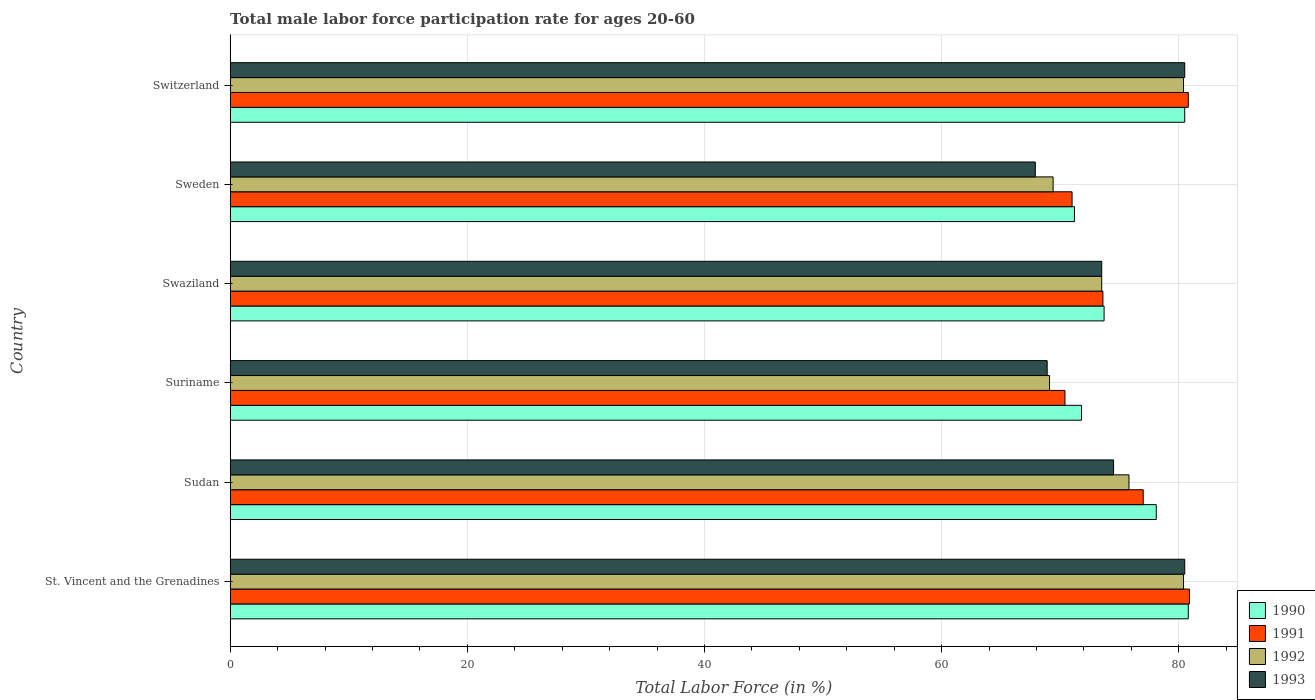How many different coloured bars are there?
Provide a short and direct response. 4. How many groups of bars are there?
Ensure brevity in your answer.  6. Are the number of bars per tick equal to the number of legend labels?
Offer a very short reply. Yes. Are the number of bars on each tick of the Y-axis equal?
Provide a succinct answer. Yes. How many bars are there on the 1st tick from the bottom?
Provide a succinct answer. 4. What is the label of the 1st group of bars from the top?
Provide a succinct answer. Switzerland. In how many cases, is the number of bars for a given country not equal to the number of legend labels?
Offer a very short reply. 0. What is the male labor force participation rate in 1991 in St. Vincent and the Grenadines?
Ensure brevity in your answer.  80.9. Across all countries, what is the maximum male labor force participation rate in 1993?
Your answer should be compact. 80.5. Across all countries, what is the minimum male labor force participation rate in 1992?
Keep it short and to the point. 69.1. In which country was the male labor force participation rate in 1993 maximum?
Your answer should be very brief. St. Vincent and the Grenadines. In which country was the male labor force participation rate in 1993 minimum?
Offer a terse response. Sweden. What is the total male labor force participation rate in 1993 in the graph?
Ensure brevity in your answer.  445.8. What is the difference between the male labor force participation rate in 1990 in Sweden and that in Switzerland?
Your response must be concise. -9.3. What is the difference between the male labor force participation rate in 1992 in Sudan and the male labor force participation rate in 1990 in Switzerland?
Your answer should be very brief. -4.7. What is the average male labor force participation rate in 1990 per country?
Offer a very short reply. 76.02. What is the difference between the male labor force participation rate in 1992 and male labor force participation rate in 1991 in Sweden?
Provide a succinct answer. -1.6. In how many countries, is the male labor force participation rate in 1993 greater than 44 %?
Your answer should be very brief. 6. What is the ratio of the male labor force participation rate in 1993 in Swaziland to that in Sweden?
Provide a succinct answer. 1.08. Is the male labor force participation rate in 1993 in St. Vincent and the Grenadines less than that in Suriname?
Offer a terse response. No. What is the difference between the highest and the second highest male labor force participation rate in 1991?
Your response must be concise. 0.1. Is the sum of the male labor force participation rate in 1990 in Sudan and Switzerland greater than the maximum male labor force participation rate in 1991 across all countries?
Give a very brief answer. Yes. Is it the case that in every country, the sum of the male labor force participation rate in 1992 and male labor force participation rate in 1993 is greater than the male labor force participation rate in 1991?
Your answer should be very brief. Yes. How many bars are there?
Keep it short and to the point. 24. How many countries are there in the graph?
Ensure brevity in your answer.  6. What is the difference between two consecutive major ticks on the X-axis?
Offer a very short reply. 20. Where does the legend appear in the graph?
Keep it short and to the point. Bottom right. How are the legend labels stacked?
Make the answer very short. Vertical. What is the title of the graph?
Keep it short and to the point. Total male labor force participation rate for ages 20-60. Does "1963" appear as one of the legend labels in the graph?
Provide a succinct answer. No. What is the label or title of the X-axis?
Ensure brevity in your answer.  Total Labor Force (in %). What is the label or title of the Y-axis?
Provide a succinct answer. Country. What is the Total Labor Force (in %) in 1990 in St. Vincent and the Grenadines?
Your answer should be very brief. 80.8. What is the Total Labor Force (in %) of 1991 in St. Vincent and the Grenadines?
Provide a succinct answer. 80.9. What is the Total Labor Force (in %) in 1992 in St. Vincent and the Grenadines?
Offer a very short reply. 80.4. What is the Total Labor Force (in %) in 1993 in St. Vincent and the Grenadines?
Your answer should be compact. 80.5. What is the Total Labor Force (in %) of 1990 in Sudan?
Provide a succinct answer. 78.1. What is the Total Labor Force (in %) in 1992 in Sudan?
Provide a short and direct response. 75.8. What is the Total Labor Force (in %) in 1993 in Sudan?
Provide a short and direct response. 74.5. What is the Total Labor Force (in %) of 1990 in Suriname?
Your answer should be very brief. 71.8. What is the Total Labor Force (in %) of 1991 in Suriname?
Ensure brevity in your answer.  70.4. What is the Total Labor Force (in %) in 1992 in Suriname?
Your answer should be very brief. 69.1. What is the Total Labor Force (in %) in 1993 in Suriname?
Your answer should be compact. 68.9. What is the Total Labor Force (in %) of 1990 in Swaziland?
Offer a terse response. 73.7. What is the Total Labor Force (in %) in 1991 in Swaziland?
Give a very brief answer. 73.6. What is the Total Labor Force (in %) of 1992 in Swaziland?
Offer a terse response. 73.5. What is the Total Labor Force (in %) in 1993 in Swaziland?
Your answer should be very brief. 73.5. What is the Total Labor Force (in %) in 1990 in Sweden?
Keep it short and to the point. 71.2. What is the Total Labor Force (in %) of 1992 in Sweden?
Ensure brevity in your answer.  69.4. What is the Total Labor Force (in %) in 1993 in Sweden?
Give a very brief answer. 67.9. What is the Total Labor Force (in %) of 1990 in Switzerland?
Give a very brief answer. 80.5. What is the Total Labor Force (in %) of 1991 in Switzerland?
Your answer should be compact. 80.8. What is the Total Labor Force (in %) of 1992 in Switzerland?
Your answer should be compact. 80.4. What is the Total Labor Force (in %) in 1993 in Switzerland?
Your answer should be compact. 80.5. Across all countries, what is the maximum Total Labor Force (in %) of 1990?
Offer a terse response. 80.8. Across all countries, what is the maximum Total Labor Force (in %) in 1991?
Give a very brief answer. 80.9. Across all countries, what is the maximum Total Labor Force (in %) of 1992?
Your answer should be very brief. 80.4. Across all countries, what is the maximum Total Labor Force (in %) of 1993?
Your response must be concise. 80.5. Across all countries, what is the minimum Total Labor Force (in %) in 1990?
Your response must be concise. 71.2. Across all countries, what is the minimum Total Labor Force (in %) of 1991?
Your answer should be compact. 70.4. Across all countries, what is the minimum Total Labor Force (in %) in 1992?
Keep it short and to the point. 69.1. Across all countries, what is the minimum Total Labor Force (in %) in 1993?
Your answer should be compact. 67.9. What is the total Total Labor Force (in %) in 1990 in the graph?
Your response must be concise. 456.1. What is the total Total Labor Force (in %) in 1991 in the graph?
Your answer should be compact. 453.7. What is the total Total Labor Force (in %) of 1992 in the graph?
Make the answer very short. 448.6. What is the total Total Labor Force (in %) in 1993 in the graph?
Offer a terse response. 445.8. What is the difference between the Total Labor Force (in %) of 1990 in St. Vincent and the Grenadines and that in Sudan?
Make the answer very short. 2.7. What is the difference between the Total Labor Force (in %) in 1991 in St. Vincent and the Grenadines and that in Sudan?
Your answer should be compact. 3.9. What is the difference between the Total Labor Force (in %) in 1992 in St. Vincent and the Grenadines and that in Sudan?
Give a very brief answer. 4.6. What is the difference between the Total Labor Force (in %) of 1993 in St. Vincent and the Grenadines and that in Sudan?
Provide a short and direct response. 6. What is the difference between the Total Labor Force (in %) in 1990 in St. Vincent and the Grenadines and that in Suriname?
Offer a very short reply. 9. What is the difference between the Total Labor Force (in %) in 1991 in St. Vincent and the Grenadines and that in Suriname?
Provide a short and direct response. 10.5. What is the difference between the Total Labor Force (in %) of 1992 in St. Vincent and the Grenadines and that in Suriname?
Offer a terse response. 11.3. What is the difference between the Total Labor Force (in %) in 1993 in St. Vincent and the Grenadines and that in Suriname?
Provide a succinct answer. 11.6. What is the difference between the Total Labor Force (in %) in 1990 in St. Vincent and the Grenadines and that in Swaziland?
Offer a very short reply. 7.1. What is the difference between the Total Labor Force (in %) in 1991 in St. Vincent and the Grenadines and that in Swaziland?
Offer a terse response. 7.3. What is the difference between the Total Labor Force (in %) in 1992 in St. Vincent and the Grenadines and that in Swaziland?
Keep it short and to the point. 6.9. What is the difference between the Total Labor Force (in %) in 1993 in St. Vincent and the Grenadines and that in Swaziland?
Your answer should be compact. 7. What is the difference between the Total Labor Force (in %) in 1993 in St. Vincent and the Grenadines and that in Sweden?
Provide a short and direct response. 12.6. What is the difference between the Total Labor Force (in %) in 1990 in St. Vincent and the Grenadines and that in Switzerland?
Make the answer very short. 0.3. What is the difference between the Total Labor Force (in %) in 1993 in St. Vincent and the Grenadines and that in Switzerland?
Offer a terse response. 0. What is the difference between the Total Labor Force (in %) in 1991 in Sudan and that in Suriname?
Offer a very short reply. 6.6. What is the difference between the Total Labor Force (in %) in 1992 in Sudan and that in Suriname?
Provide a short and direct response. 6.7. What is the difference between the Total Labor Force (in %) of 1993 in Sudan and that in Suriname?
Give a very brief answer. 5.6. What is the difference between the Total Labor Force (in %) in 1990 in Sudan and that in Swaziland?
Offer a terse response. 4.4. What is the difference between the Total Labor Force (in %) of 1991 in Sudan and that in Sweden?
Give a very brief answer. 6. What is the difference between the Total Labor Force (in %) in 1991 in Sudan and that in Switzerland?
Your response must be concise. -3.8. What is the difference between the Total Labor Force (in %) in 1992 in Sudan and that in Switzerland?
Ensure brevity in your answer.  -4.6. What is the difference between the Total Labor Force (in %) of 1990 in Suriname and that in Swaziland?
Your answer should be very brief. -1.9. What is the difference between the Total Labor Force (in %) of 1992 in Suriname and that in Swaziland?
Offer a very short reply. -4.4. What is the difference between the Total Labor Force (in %) of 1990 in Suriname and that in Sweden?
Ensure brevity in your answer.  0.6. What is the difference between the Total Labor Force (in %) in 1991 in Suriname and that in Sweden?
Keep it short and to the point. -0.6. What is the difference between the Total Labor Force (in %) of 1993 in Suriname and that in Sweden?
Your response must be concise. 1. What is the difference between the Total Labor Force (in %) of 1990 in Suriname and that in Switzerland?
Offer a terse response. -8.7. What is the difference between the Total Labor Force (in %) in 1992 in Suriname and that in Switzerland?
Offer a very short reply. -11.3. What is the difference between the Total Labor Force (in %) of 1993 in Suriname and that in Switzerland?
Give a very brief answer. -11.6. What is the difference between the Total Labor Force (in %) of 1990 in Swaziland and that in Sweden?
Your answer should be very brief. 2.5. What is the difference between the Total Labor Force (in %) of 1992 in Swaziland and that in Sweden?
Provide a succinct answer. 4.1. What is the difference between the Total Labor Force (in %) in 1991 in Swaziland and that in Switzerland?
Your response must be concise. -7.2. What is the difference between the Total Labor Force (in %) of 1993 in Swaziland and that in Switzerland?
Your answer should be compact. -7. What is the difference between the Total Labor Force (in %) in 1993 in Sweden and that in Switzerland?
Give a very brief answer. -12.6. What is the difference between the Total Labor Force (in %) in 1992 in St. Vincent and the Grenadines and the Total Labor Force (in %) in 1993 in Sudan?
Your answer should be very brief. 5.9. What is the difference between the Total Labor Force (in %) in 1990 in St. Vincent and the Grenadines and the Total Labor Force (in %) in 1991 in Suriname?
Provide a succinct answer. 10.4. What is the difference between the Total Labor Force (in %) in 1991 in St. Vincent and the Grenadines and the Total Labor Force (in %) in 1992 in Suriname?
Ensure brevity in your answer.  11.8. What is the difference between the Total Labor Force (in %) of 1990 in St. Vincent and the Grenadines and the Total Labor Force (in %) of 1991 in Swaziland?
Offer a terse response. 7.2. What is the difference between the Total Labor Force (in %) in 1990 in St. Vincent and the Grenadines and the Total Labor Force (in %) in 1993 in Sweden?
Give a very brief answer. 12.9. What is the difference between the Total Labor Force (in %) of 1991 in St. Vincent and the Grenadines and the Total Labor Force (in %) of 1993 in Sweden?
Make the answer very short. 13. What is the difference between the Total Labor Force (in %) of 1992 in St. Vincent and the Grenadines and the Total Labor Force (in %) of 1993 in Sweden?
Ensure brevity in your answer.  12.5. What is the difference between the Total Labor Force (in %) of 1990 in St. Vincent and the Grenadines and the Total Labor Force (in %) of 1991 in Switzerland?
Keep it short and to the point. 0. What is the difference between the Total Labor Force (in %) in 1991 in St. Vincent and the Grenadines and the Total Labor Force (in %) in 1993 in Switzerland?
Give a very brief answer. 0.4. What is the difference between the Total Labor Force (in %) in 1990 in Sudan and the Total Labor Force (in %) in 1992 in Suriname?
Offer a terse response. 9. What is the difference between the Total Labor Force (in %) in 1990 in Sudan and the Total Labor Force (in %) in 1993 in Suriname?
Offer a very short reply. 9.2. What is the difference between the Total Labor Force (in %) in 1991 in Sudan and the Total Labor Force (in %) in 1992 in Suriname?
Offer a very short reply. 7.9. What is the difference between the Total Labor Force (in %) of 1991 in Sudan and the Total Labor Force (in %) of 1993 in Suriname?
Give a very brief answer. 8.1. What is the difference between the Total Labor Force (in %) of 1990 in Sudan and the Total Labor Force (in %) of 1992 in Swaziland?
Your response must be concise. 4.6. What is the difference between the Total Labor Force (in %) of 1991 in Sudan and the Total Labor Force (in %) of 1993 in Swaziland?
Your answer should be compact. 3.5. What is the difference between the Total Labor Force (in %) of 1990 in Sudan and the Total Labor Force (in %) of 1991 in Sweden?
Offer a very short reply. 7.1. What is the difference between the Total Labor Force (in %) of 1990 in Sudan and the Total Labor Force (in %) of 1992 in Sweden?
Ensure brevity in your answer.  8.7. What is the difference between the Total Labor Force (in %) of 1990 in Sudan and the Total Labor Force (in %) of 1993 in Sweden?
Your answer should be compact. 10.2. What is the difference between the Total Labor Force (in %) of 1991 in Sudan and the Total Labor Force (in %) of 1993 in Sweden?
Provide a short and direct response. 9.1. What is the difference between the Total Labor Force (in %) of 1992 in Sudan and the Total Labor Force (in %) of 1993 in Sweden?
Your response must be concise. 7.9. What is the difference between the Total Labor Force (in %) in 1990 in Sudan and the Total Labor Force (in %) in 1991 in Switzerland?
Provide a succinct answer. -2.7. What is the difference between the Total Labor Force (in %) of 1990 in Sudan and the Total Labor Force (in %) of 1992 in Switzerland?
Make the answer very short. -2.3. What is the difference between the Total Labor Force (in %) of 1990 in Sudan and the Total Labor Force (in %) of 1993 in Switzerland?
Your response must be concise. -2.4. What is the difference between the Total Labor Force (in %) of 1992 in Sudan and the Total Labor Force (in %) of 1993 in Switzerland?
Offer a very short reply. -4.7. What is the difference between the Total Labor Force (in %) in 1990 in Suriname and the Total Labor Force (in %) in 1991 in Swaziland?
Your response must be concise. -1.8. What is the difference between the Total Labor Force (in %) of 1991 in Suriname and the Total Labor Force (in %) of 1993 in Swaziland?
Offer a terse response. -3.1. What is the difference between the Total Labor Force (in %) of 1992 in Suriname and the Total Labor Force (in %) of 1993 in Swaziland?
Keep it short and to the point. -4.4. What is the difference between the Total Labor Force (in %) in 1990 in Suriname and the Total Labor Force (in %) in 1991 in Sweden?
Offer a very short reply. 0.8. What is the difference between the Total Labor Force (in %) in 1991 in Suriname and the Total Labor Force (in %) in 1992 in Sweden?
Give a very brief answer. 1. What is the difference between the Total Labor Force (in %) of 1990 in Suriname and the Total Labor Force (in %) of 1991 in Switzerland?
Your answer should be compact. -9. What is the difference between the Total Labor Force (in %) of 1990 in Suriname and the Total Labor Force (in %) of 1993 in Switzerland?
Provide a succinct answer. -8.7. What is the difference between the Total Labor Force (in %) of 1991 in Suriname and the Total Labor Force (in %) of 1992 in Switzerland?
Keep it short and to the point. -10. What is the difference between the Total Labor Force (in %) of 1992 in Suriname and the Total Labor Force (in %) of 1993 in Switzerland?
Your answer should be very brief. -11.4. What is the difference between the Total Labor Force (in %) of 1990 in Swaziland and the Total Labor Force (in %) of 1991 in Sweden?
Keep it short and to the point. 2.7. What is the difference between the Total Labor Force (in %) of 1990 in Swaziland and the Total Labor Force (in %) of 1993 in Sweden?
Offer a very short reply. 5.8. What is the difference between the Total Labor Force (in %) in 1991 in Swaziland and the Total Labor Force (in %) in 1993 in Sweden?
Ensure brevity in your answer.  5.7. What is the difference between the Total Labor Force (in %) of 1990 in Swaziland and the Total Labor Force (in %) of 1993 in Switzerland?
Your answer should be very brief. -6.8. What is the difference between the Total Labor Force (in %) of 1990 in Sweden and the Total Labor Force (in %) of 1992 in Switzerland?
Keep it short and to the point. -9.2. What is the difference between the Total Labor Force (in %) in 1991 in Sweden and the Total Labor Force (in %) in 1992 in Switzerland?
Provide a succinct answer. -9.4. What is the difference between the Total Labor Force (in %) of 1991 in Sweden and the Total Labor Force (in %) of 1993 in Switzerland?
Make the answer very short. -9.5. What is the average Total Labor Force (in %) of 1990 per country?
Provide a short and direct response. 76.02. What is the average Total Labor Force (in %) of 1991 per country?
Your response must be concise. 75.62. What is the average Total Labor Force (in %) in 1992 per country?
Offer a terse response. 74.77. What is the average Total Labor Force (in %) of 1993 per country?
Offer a very short reply. 74.3. What is the difference between the Total Labor Force (in %) of 1990 and Total Labor Force (in %) of 1992 in St. Vincent and the Grenadines?
Offer a very short reply. 0.4. What is the difference between the Total Labor Force (in %) in 1991 and Total Labor Force (in %) in 1992 in St. Vincent and the Grenadines?
Keep it short and to the point. 0.5. What is the difference between the Total Labor Force (in %) of 1992 and Total Labor Force (in %) of 1993 in St. Vincent and the Grenadines?
Make the answer very short. -0.1. What is the difference between the Total Labor Force (in %) of 1990 and Total Labor Force (in %) of 1991 in Sudan?
Offer a very short reply. 1.1. What is the difference between the Total Labor Force (in %) of 1991 and Total Labor Force (in %) of 1992 in Sudan?
Offer a very short reply. 1.2. What is the difference between the Total Labor Force (in %) of 1991 and Total Labor Force (in %) of 1993 in Sudan?
Keep it short and to the point. 2.5. What is the difference between the Total Labor Force (in %) in 1992 and Total Labor Force (in %) in 1993 in Sudan?
Ensure brevity in your answer.  1.3. What is the difference between the Total Labor Force (in %) in 1990 and Total Labor Force (in %) in 1993 in Suriname?
Offer a very short reply. 2.9. What is the difference between the Total Labor Force (in %) of 1991 and Total Labor Force (in %) of 1992 in Suriname?
Give a very brief answer. 1.3. What is the difference between the Total Labor Force (in %) in 1991 and Total Labor Force (in %) in 1993 in Suriname?
Provide a short and direct response. 1.5. What is the difference between the Total Labor Force (in %) in 1990 and Total Labor Force (in %) in 1991 in Swaziland?
Offer a terse response. 0.1. What is the difference between the Total Labor Force (in %) of 1990 and Total Labor Force (in %) of 1992 in Swaziland?
Keep it short and to the point. 0.2. What is the difference between the Total Labor Force (in %) of 1990 and Total Labor Force (in %) of 1993 in Swaziland?
Provide a short and direct response. 0.2. What is the difference between the Total Labor Force (in %) in 1992 and Total Labor Force (in %) in 1993 in Swaziland?
Offer a terse response. 0. What is the difference between the Total Labor Force (in %) in 1990 and Total Labor Force (in %) in 1991 in Sweden?
Offer a terse response. 0.2. What is the difference between the Total Labor Force (in %) of 1990 and Total Labor Force (in %) of 1993 in Sweden?
Give a very brief answer. 3.3. What is the difference between the Total Labor Force (in %) in 1991 and Total Labor Force (in %) in 1992 in Sweden?
Your answer should be compact. 1.6. What is the difference between the Total Labor Force (in %) in 1991 and Total Labor Force (in %) in 1993 in Sweden?
Provide a short and direct response. 3.1. What is the difference between the Total Labor Force (in %) in 1992 and Total Labor Force (in %) in 1993 in Sweden?
Your answer should be compact. 1.5. What is the difference between the Total Labor Force (in %) of 1990 and Total Labor Force (in %) of 1991 in Switzerland?
Your answer should be compact. -0.3. What is the difference between the Total Labor Force (in %) of 1991 and Total Labor Force (in %) of 1992 in Switzerland?
Make the answer very short. 0.4. What is the difference between the Total Labor Force (in %) of 1991 and Total Labor Force (in %) of 1993 in Switzerland?
Ensure brevity in your answer.  0.3. What is the ratio of the Total Labor Force (in %) of 1990 in St. Vincent and the Grenadines to that in Sudan?
Ensure brevity in your answer.  1.03. What is the ratio of the Total Labor Force (in %) of 1991 in St. Vincent and the Grenadines to that in Sudan?
Ensure brevity in your answer.  1.05. What is the ratio of the Total Labor Force (in %) of 1992 in St. Vincent and the Grenadines to that in Sudan?
Offer a very short reply. 1.06. What is the ratio of the Total Labor Force (in %) of 1993 in St. Vincent and the Grenadines to that in Sudan?
Keep it short and to the point. 1.08. What is the ratio of the Total Labor Force (in %) of 1990 in St. Vincent and the Grenadines to that in Suriname?
Provide a succinct answer. 1.13. What is the ratio of the Total Labor Force (in %) in 1991 in St. Vincent and the Grenadines to that in Suriname?
Give a very brief answer. 1.15. What is the ratio of the Total Labor Force (in %) in 1992 in St. Vincent and the Grenadines to that in Suriname?
Provide a succinct answer. 1.16. What is the ratio of the Total Labor Force (in %) of 1993 in St. Vincent and the Grenadines to that in Suriname?
Your response must be concise. 1.17. What is the ratio of the Total Labor Force (in %) in 1990 in St. Vincent and the Grenadines to that in Swaziland?
Offer a very short reply. 1.1. What is the ratio of the Total Labor Force (in %) in 1991 in St. Vincent and the Grenadines to that in Swaziland?
Provide a short and direct response. 1.1. What is the ratio of the Total Labor Force (in %) of 1992 in St. Vincent and the Grenadines to that in Swaziland?
Make the answer very short. 1.09. What is the ratio of the Total Labor Force (in %) in 1993 in St. Vincent and the Grenadines to that in Swaziland?
Offer a terse response. 1.1. What is the ratio of the Total Labor Force (in %) of 1990 in St. Vincent and the Grenadines to that in Sweden?
Offer a terse response. 1.13. What is the ratio of the Total Labor Force (in %) in 1991 in St. Vincent and the Grenadines to that in Sweden?
Your answer should be compact. 1.14. What is the ratio of the Total Labor Force (in %) of 1992 in St. Vincent and the Grenadines to that in Sweden?
Your response must be concise. 1.16. What is the ratio of the Total Labor Force (in %) of 1993 in St. Vincent and the Grenadines to that in Sweden?
Provide a short and direct response. 1.19. What is the ratio of the Total Labor Force (in %) in 1990 in St. Vincent and the Grenadines to that in Switzerland?
Keep it short and to the point. 1. What is the ratio of the Total Labor Force (in %) of 1992 in St. Vincent and the Grenadines to that in Switzerland?
Give a very brief answer. 1. What is the ratio of the Total Labor Force (in %) in 1990 in Sudan to that in Suriname?
Offer a very short reply. 1.09. What is the ratio of the Total Labor Force (in %) of 1991 in Sudan to that in Suriname?
Provide a short and direct response. 1.09. What is the ratio of the Total Labor Force (in %) in 1992 in Sudan to that in Suriname?
Your response must be concise. 1.1. What is the ratio of the Total Labor Force (in %) in 1993 in Sudan to that in Suriname?
Give a very brief answer. 1.08. What is the ratio of the Total Labor Force (in %) of 1990 in Sudan to that in Swaziland?
Offer a terse response. 1.06. What is the ratio of the Total Labor Force (in %) in 1991 in Sudan to that in Swaziland?
Make the answer very short. 1.05. What is the ratio of the Total Labor Force (in %) in 1992 in Sudan to that in Swaziland?
Offer a very short reply. 1.03. What is the ratio of the Total Labor Force (in %) of 1993 in Sudan to that in Swaziland?
Provide a succinct answer. 1.01. What is the ratio of the Total Labor Force (in %) of 1990 in Sudan to that in Sweden?
Provide a succinct answer. 1.1. What is the ratio of the Total Labor Force (in %) of 1991 in Sudan to that in Sweden?
Offer a terse response. 1.08. What is the ratio of the Total Labor Force (in %) of 1992 in Sudan to that in Sweden?
Your answer should be compact. 1.09. What is the ratio of the Total Labor Force (in %) of 1993 in Sudan to that in Sweden?
Keep it short and to the point. 1.1. What is the ratio of the Total Labor Force (in %) of 1990 in Sudan to that in Switzerland?
Ensure brevity in your answer.  0.97. What is the ratio of the Total Labor Force (in %) in 1991 in Sudan to that in Switzerland?
Your answer should be very brief. 0.95. What is the ratio of the Total Labor Force (in %) of 1992 in Sudan to that in Switzerland?
Provide a succinct answer. 0.94. What is the ratio of the Total Labor Force (in %) of 1993 in Sudan to that in Switzerland?
Offer a very short reply. 0.93. What is the ratio of the Total Labor Force (in %) in 1990 in Suriname to that in Swaziland?
Ensure brevity in your answer.  0.97. What is the ratio of the Total Labor Force (in %) in 1991 in Suriname to that in Swaziland?
Provide a short and direct response. 0.96. What is the ratio of the Total Labor Force (in %) of 1992 in Suriname to that in Swaziland?
Provide a succinct answer. 0.94. What is the ratio of the Total Labor Force (in %) of 1993 in Suriname to that in Swaziland?
Ensure brevity in your answer.  0.94. What is the ratio of the Total Labor Force (in %) in 1990 in Suriname to that in Sweden?
Your response must be concise. 1.01. What is the ratio of the Total Labor Force (in %) in 1991 in Suriname to that in Sweden?
Offer a terse response. 0.99. What is the ratio of the Total Labor Force (in %) of 1992 in Suriname to that in Sweden?
Give a very brief answer. 1. What is the ratio of the Total Labor Force (in %) of 1993 in Suriname to that in Sweden?
Your answer should be very brief. 1.01. What is the ratio of the Total Labor Force (in %) in 1990 in Suriname to that in Switzerland?
Your answer should be very brief. 0.89. What is the ratio of the Total Labor Force (in %) of 1991 in Suriname to that in Switzerland?
Make the answer very short. 0.87. What is the ratio of the Total Labor Force (in %) of 1992 in Suriname to that in Switzerland?
Make the answer very short. 0.86. What is the ratio of the Total Labor Force (in %) in 1993 in Suriname to that in Switzerland?
Provide a succinct answer. 0.86. What is the ratio of the Total Labor Force (in %) of 1990 in Swaziland to that in Sweden?
Offer a terse response. 1.04. What is the ratio of the Total Labor Force (in %) in 1991 in Swaziland to that in Sweden?
Your answer should be very brief. 1.04. What is the ratio of the Total Labor Force (in %) in 1992 in Swaziland to that in Sweden?
Offer a very short reply. 1.06. What is the ratio of the Total Labor Force (in %) of 1993 in Swaziland to that in Sweden?
Offer a very short reply. 1.08. What is the ratio of the Total Labor Force (in %) in 1990 in Swaziland to that in Switzerland?
Provide a short and direct response. 0.92. What is the ratio of the Total Labor Force (in %) of 1991 in Swaziland to that in Switzerland?
Offer a terse response. 0.91. What is the ratio of the Total Labor Force (in %) in 1992 in Swaziland to that in Switzerland?
Provide a succinct answer. 0.91. What is the ratio of the Total Labor Force (in %) in 1990 in Sweden to that in Switzerland?
Your response must be concise. 0.88. What is the ratio of the Total Labor Force (in %) of 1991 in Sweden to that in Switzerland?
Give a very brief answer. 0.88. What is the ratio of the Total Labor Force (in %) of 1992 in Sweden to that in Switzerland?
Offer a very short reply. 0.86. What is the ratio of the Total Labor Force (in %) of 1993 in Sweden to that in Switzerland?
Keep it short and to the point. 0.84. What is the difference between the highest and the second highest Total Labor Force (in %) in 1990?
Offer a very short reply. 0.3. What is the difference between the highest and the second highest Total Labor Force (in %) in 1993?
Provide a succinct answer. 0. What is the difference between the highest and the lowest Total Labor Force (in %) in 1990?
Your response must be concise. 9.6. What is the difference between the highest and the lowest Total Labor Force (in %) of 1993?
Keep it short and to the point. 12.6. 